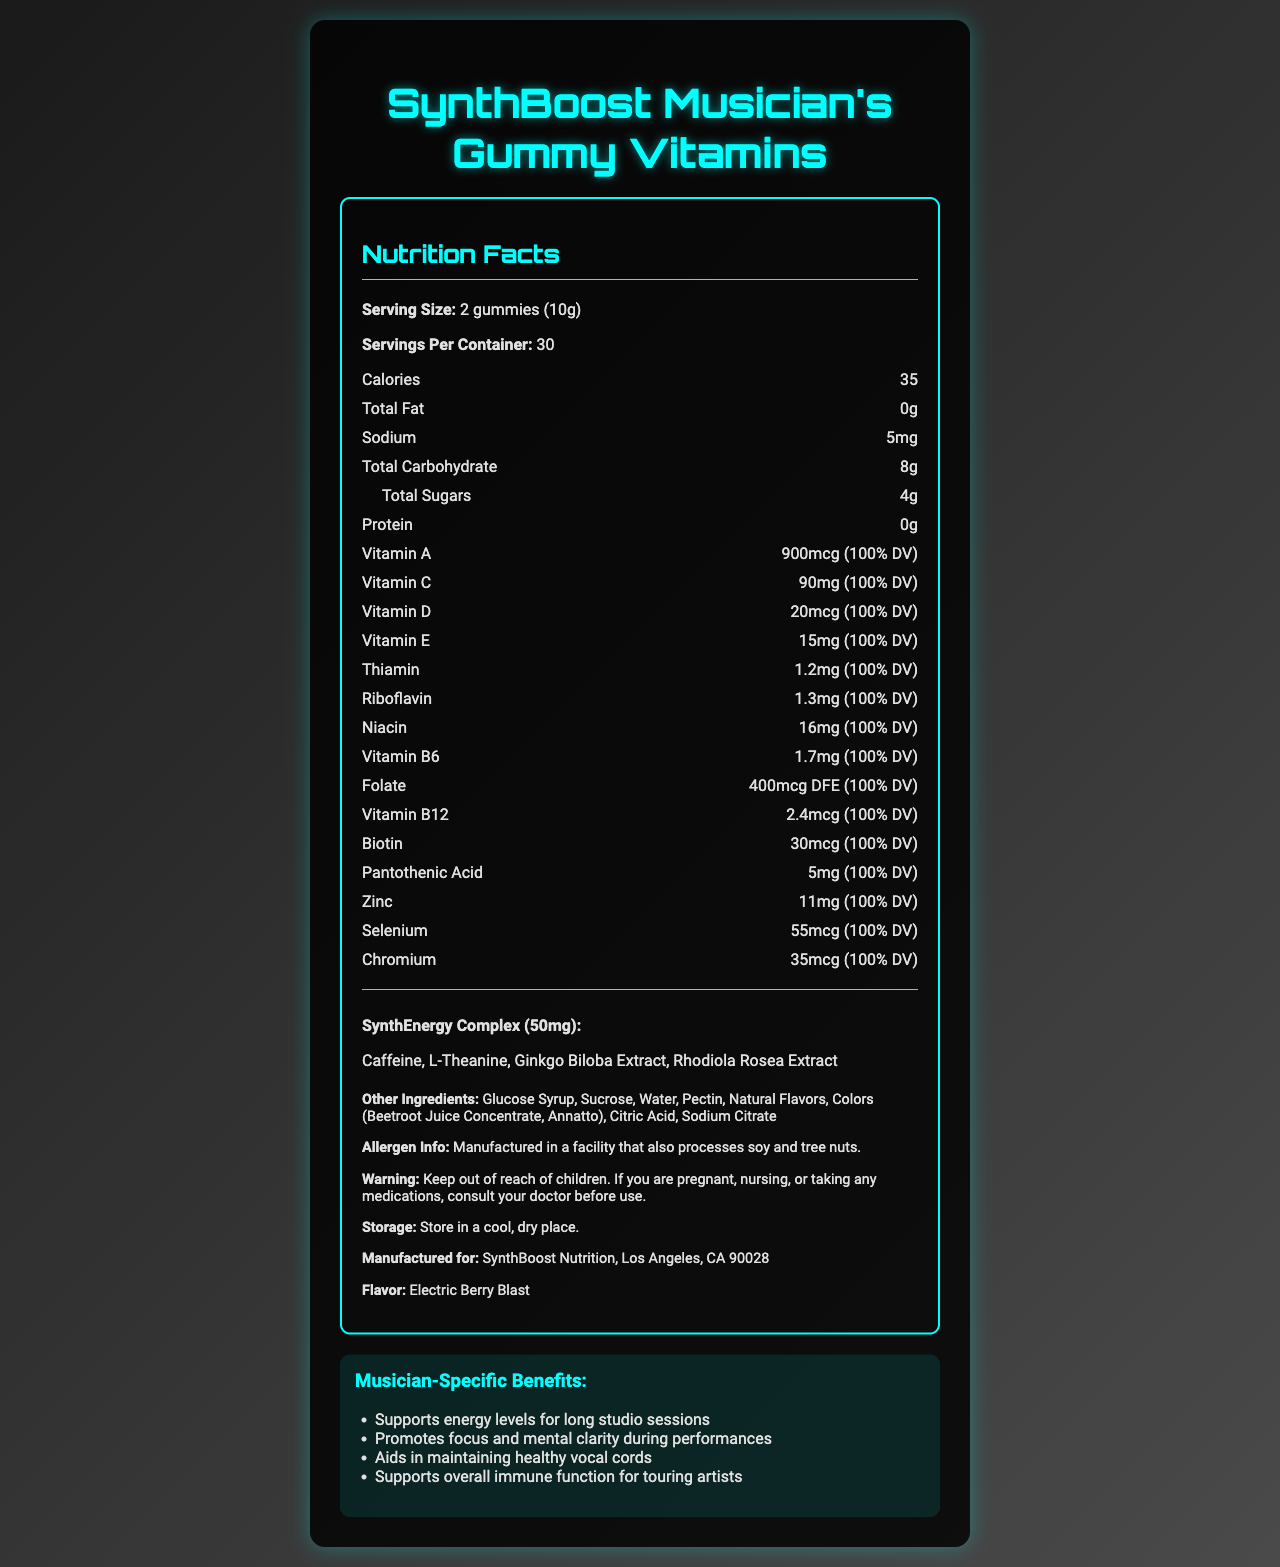what is the serving size for SynthBoost Musician's Gummy Vitamins? The serving size is listed as 2 gummies, equivalent to 10 grams, in the nutrition facts.
Answer: 2 gummies (10g) how many servings does one container of SynthBoost Musician's Gummy Vitamins contain? The document states there are 30 servings per container.
Answer: 30 how many calories are in one serving of SynthBoost Musician's Gummy Vitamins? The document indicates that each serving contains 35 calories.
Answer: 35 what is the amount of Vitamin C per serving? The document specifies that each serving contains 90mg of Vitamin C, which is 100% of the daily value.
Answer: 90mg (100% DV) what proprietary blend is included in the SynthBoost Musician's Gummy Vitamins? The proprietary blend included in the gummies is called "SynthEnergy Complex." This is mentioned under the proprietary blend section.
Answer: SynthEnergy Complex which of the following is NOT an ingredient in the SynthEnergy Complex? A. Caffeine B. L-Theanine C. Vitamin B12 D. Ginkgo Biloba Extract The SynthEnergy Complex includes Caffeine, L-Theanine, Ginkgo Biloba Extract, and Rhodiola Rosea Extract. Vitamin B12 is not listed as part of this blend.
Answer: C. Vitamin B12 what flavor are the SynthBoost Musician's Gummy Vitamins? A. Electric Berry Blast B. Citrus Symphony C. Rockin' Raspberry D. Melodic Mango The flavor is stated to be "Electric Berry Blast."
Answer: A. Electric Berry Blast are SynthBoost Musician's Gummy Vitamins safe for children? The warning clearly states to keep the gummies out of reach of children.
Answer: No can we determine the price of SynthBoost Musician's Gummy Vitamins from the document? The document does not provide any information about the price of the gummy vitamins.
Answer: Cannot be determined summarize the main idea of the SynthBoost Musician's Gummy Vitamins nutrition label. The label provides detailed information on the product's ingredients, nutritional benefits, serving size, proprietary blend, and specific warnings, targeting the needs of musicians.
Answer: Summary: SynthBoost Musician's Gummy Vitamins are a specially formulated supplement tailored for musicians, containing a variety of essential vitamins and minerals to support energy, focus, vocal health, and immune function. The gummies include a SynthEnergy Complex proprietary blend and come in an Electric Berry Blast flavor. Each container holds 30 servings, with 2 gummies per serving. The product has clear nutritional information, ingredients, allergen info, and storage instructions. do SynthBoost Musician's Gummy Vitamins contain any fat? The document states that the total fat content per serving is 0g.
Answer: No identify the other ingredients apart from the active proprietary blend. The document lists these as the other ingredients included in the gummy vitamins.
Answer: Glucose Syrup, Sucrose, Water, Pectin, Natural Flavors, Colors (Beetroot Juice Concentrate, Annatto), Citric Acid, Sodium Citrate which vitamin provides 2.4mcg per serving in SynthBoost Musician's Gummy Vitamins? A. Vitamin A B. Vitamin D C. Vitamin B12 D. Vitamin B6 The document states that each serving contains 2.4mcg of Vitamin B12, amounting to 100% DV.
Answer: C. Vitamin B12 are SynthBoost Musician's Gummy Vitamins free of common allergens? The label does mention that the product is manufactured in a facility that processes soy and tree nuts, but it doesn’t explicitly state if the gummies themselves contain these allergens or are entirely free of other common allergens.
Answer: Not enough information do the SynthBoost Musician's Gummy Vitamins help with energy levels during long studio sessions? One of the musician-specific benefits listed is that the gummies "support energy levels for long studio sessions."
Answer: Yes 